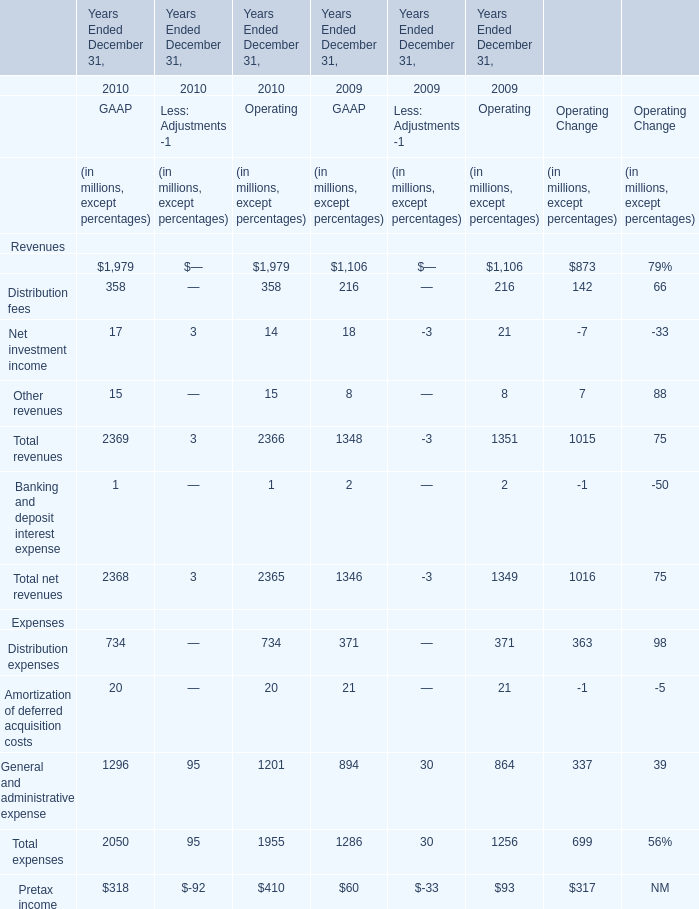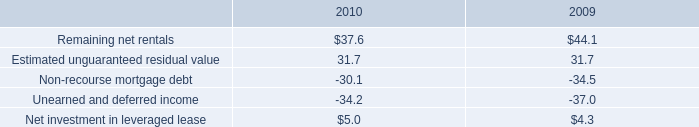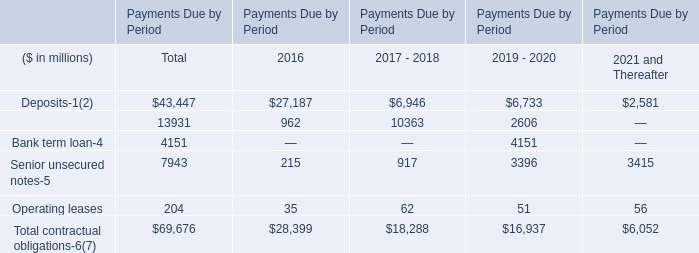what is the growth rate in revenues generated through subleasing in 2010? 
Computations: ((5.9 - 5.2) / 5.2)
Answer: 0.13462. 